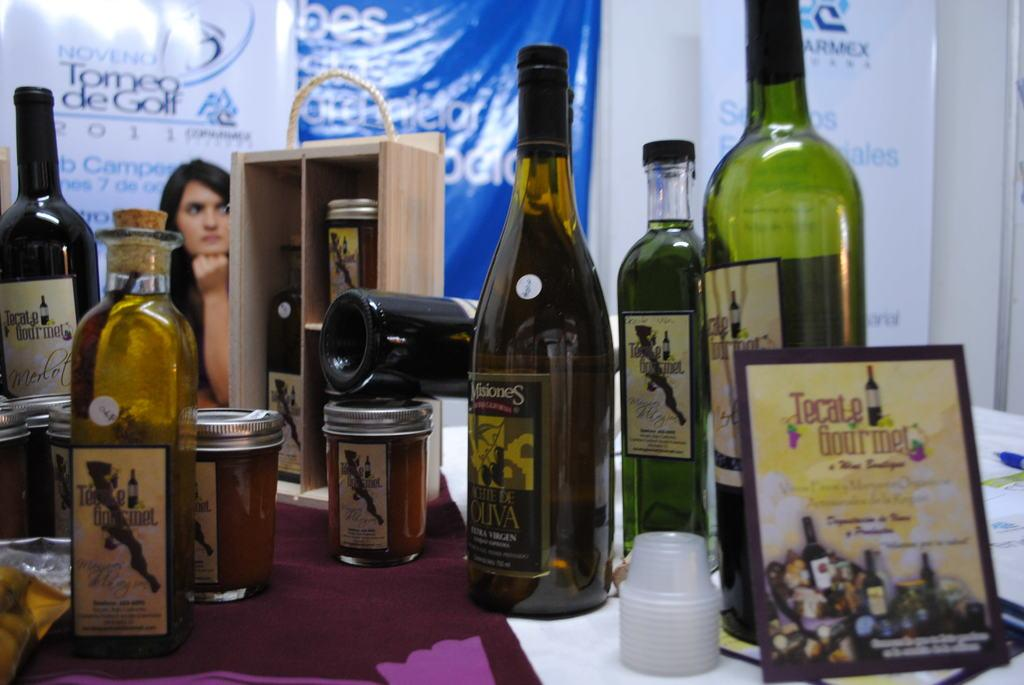<image>
Offer a succinct explanation of the picture presented. Some bottles of wine with Tomea de Golf in the background. 